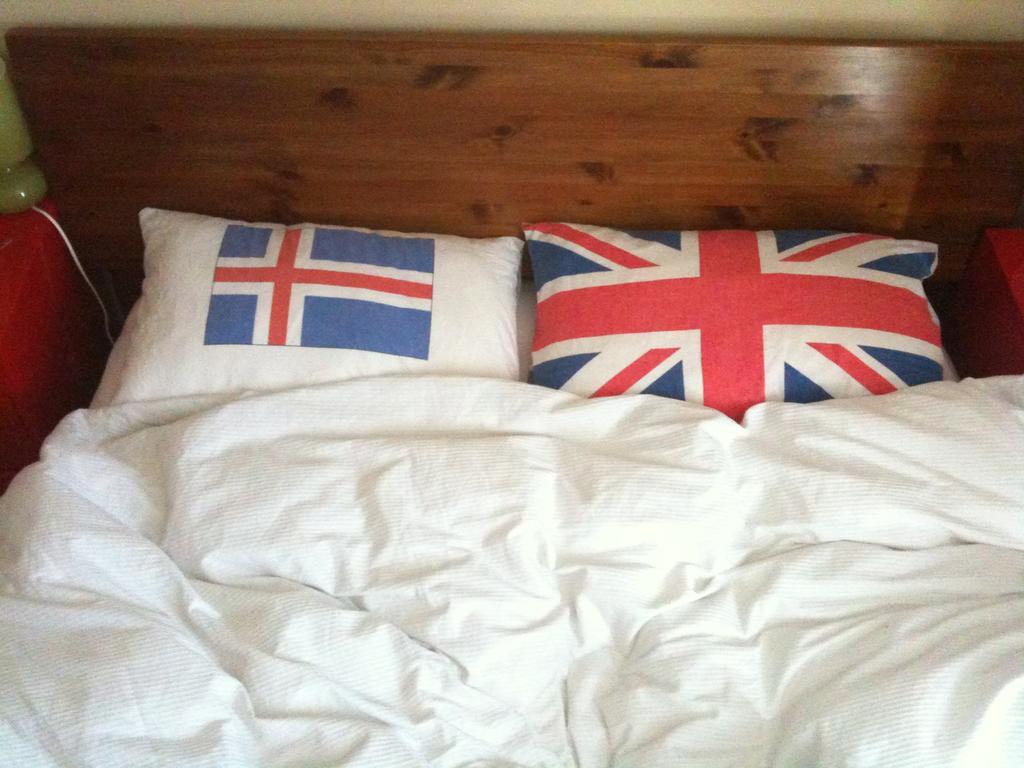Can you describe this image briefly? In the image we can see there is a bed on which there is white colour blanket and the pillows are of flag and there is wooden bed. 